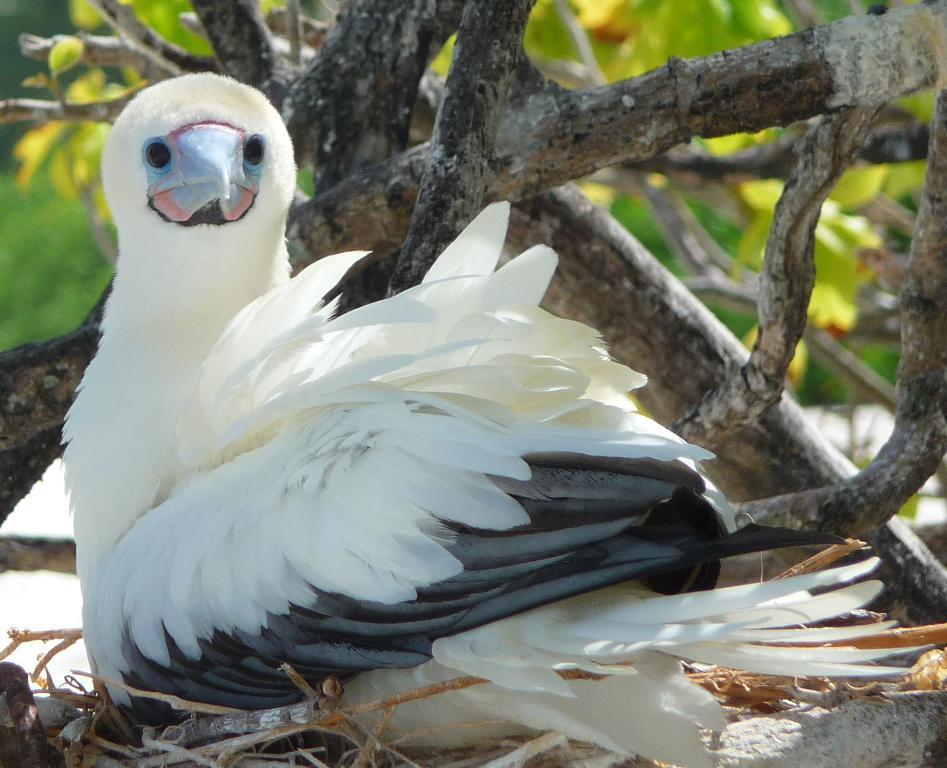How would you summarize this image in a sentence or two? In this image I can see few tree branches, leaves and in the front I can see a white and black colour bird. 